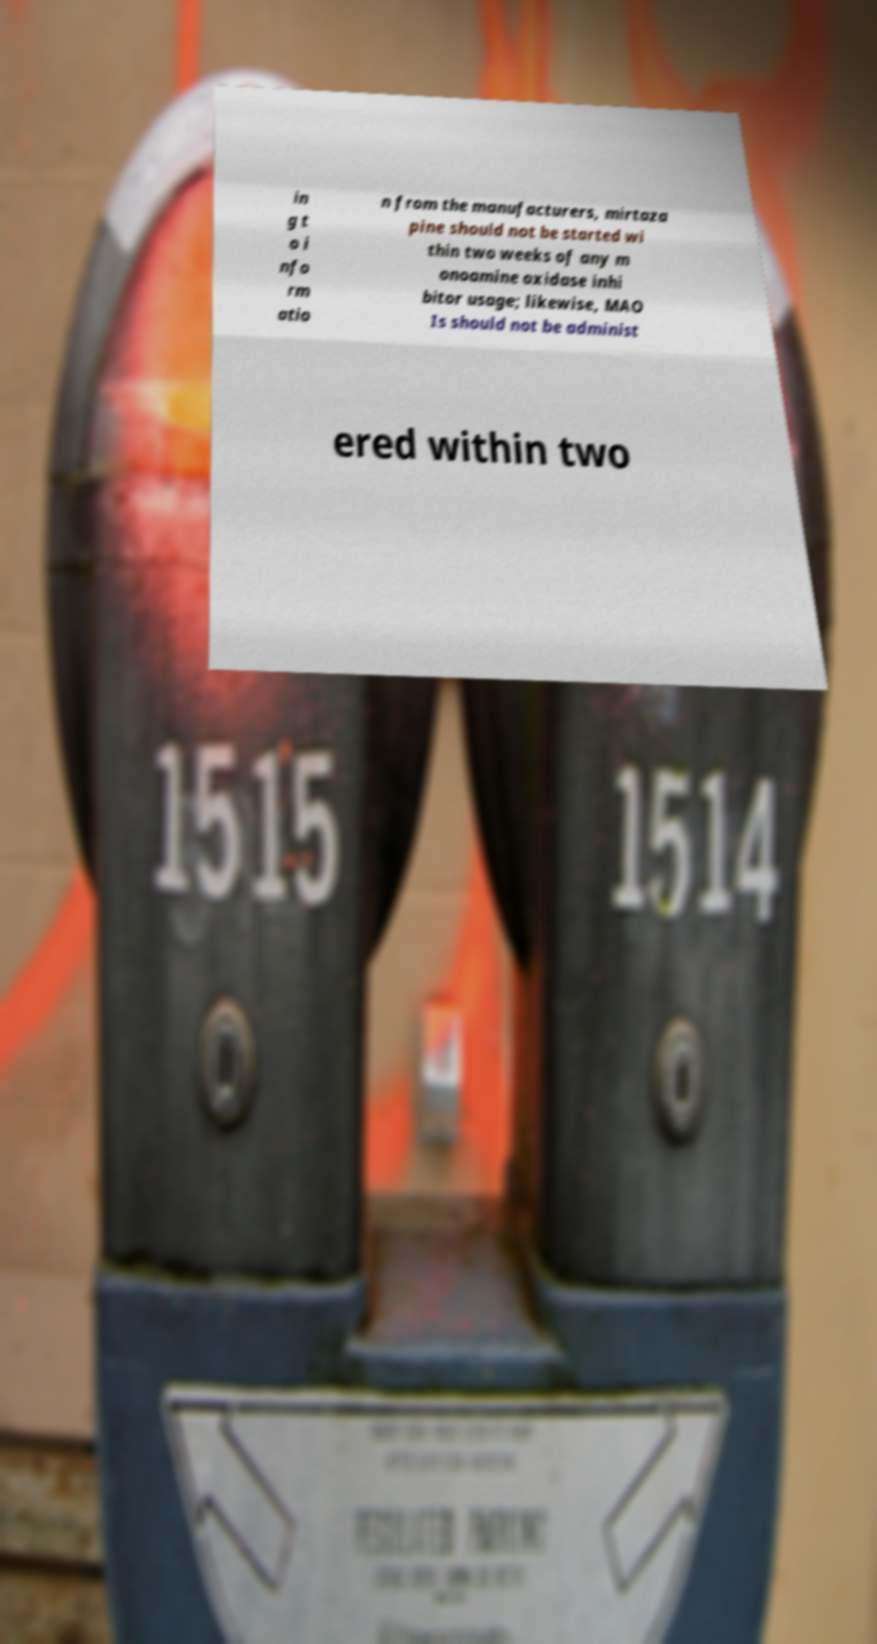Could you assist in decoding the text presented in this image and type it out clearly? in g t o i nfo rm atio n from the manufacturers, mirtaza pine should not be started wi thin two weeks of any m onoamine oxidase inhi bitor usage; likewise, MAO Is should not be administ ered within two 